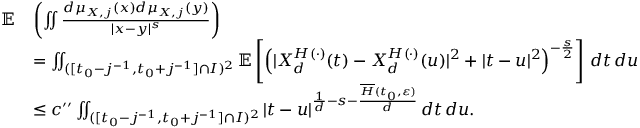Convert formula to latex. <formula><loc_0><loc_0><loc_500><loc_500>\begin{array} { r l } { \mathbb { E } } & { \left ( \iint \frac { d \mu _ { X , j } ( x ) d \mu _ { X , j } ( y ) } { | x - y | ^ { s } } \right ) } \\ & { = \iint _ { ( [ t _ { 0 } - j ^ { - 1 } , t _ { 0 } + j ^ { - 1 } ] \cap I ) ^ { 2 } } \mathbb { E } \left [ \left ( | X _ { d } ^ { H ( \cdot ) } ( t ) - X _ { d } ^ { H ( \cdot ) } ( u ) | ^ { 2 } + | t - u | ^ { 2 } \right ) ^ { - \frac { s } { 2 } } \right ] \, d t \, d u } \\ & { \leq c ^ { \prime \prime } \iint _ { ( [ t _ { 0 } - j ^ { - 1 } , t _ { 0 } + j ^ { - 1 } ] \cap I ) ^ { 2 } } | t - u | ^ { \frac { 1 } { d } - s - \frac { \overline { H } ( t _ { 0 } , \varepsilon ) } { d } } \, d t \, d u . } \end{array}</formula> 